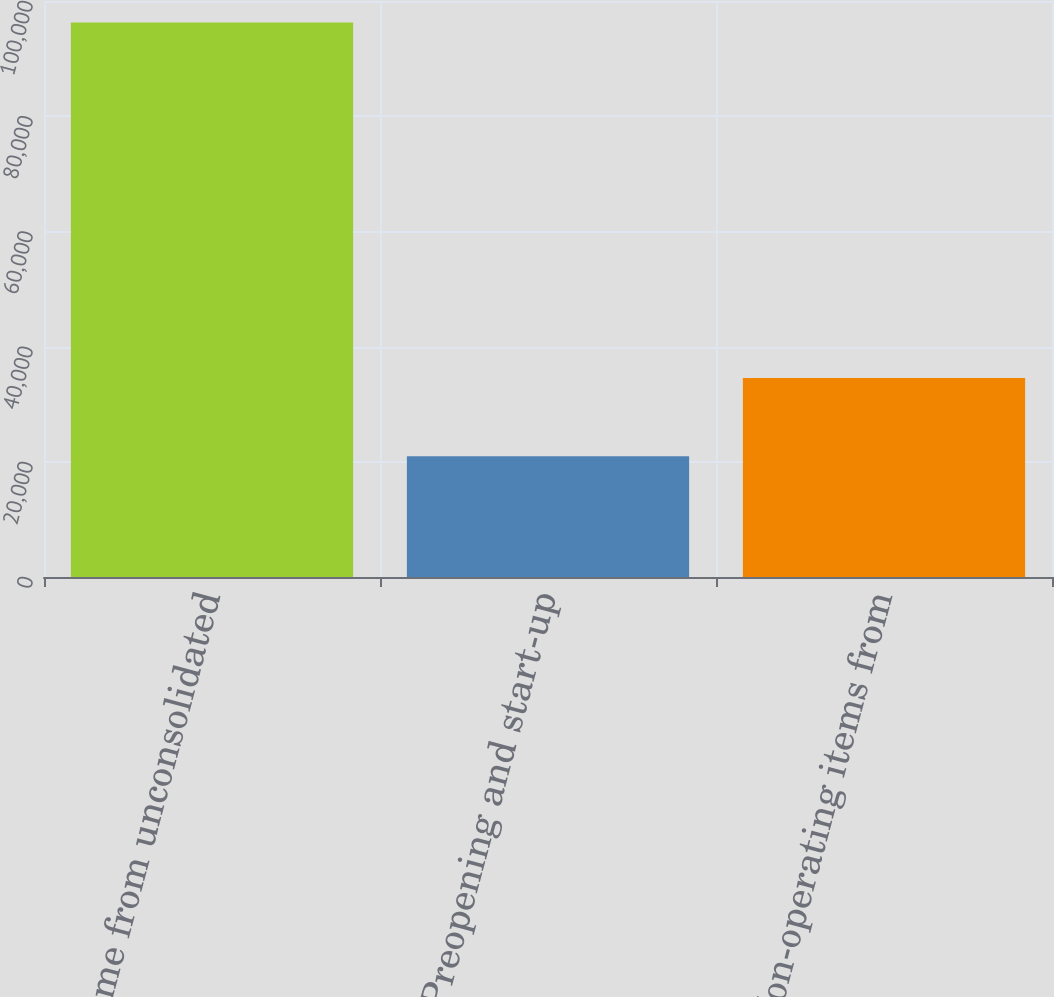<chart> <loc_0><loc_0><loc_500><loc_500><bar_chart><fcel>Income from unconsolidated<fcel>Preopening and start-up<fcel>Non-operating items from<nl><fcel>96271<fcel>20960<fcel>34559<nl></chart> 